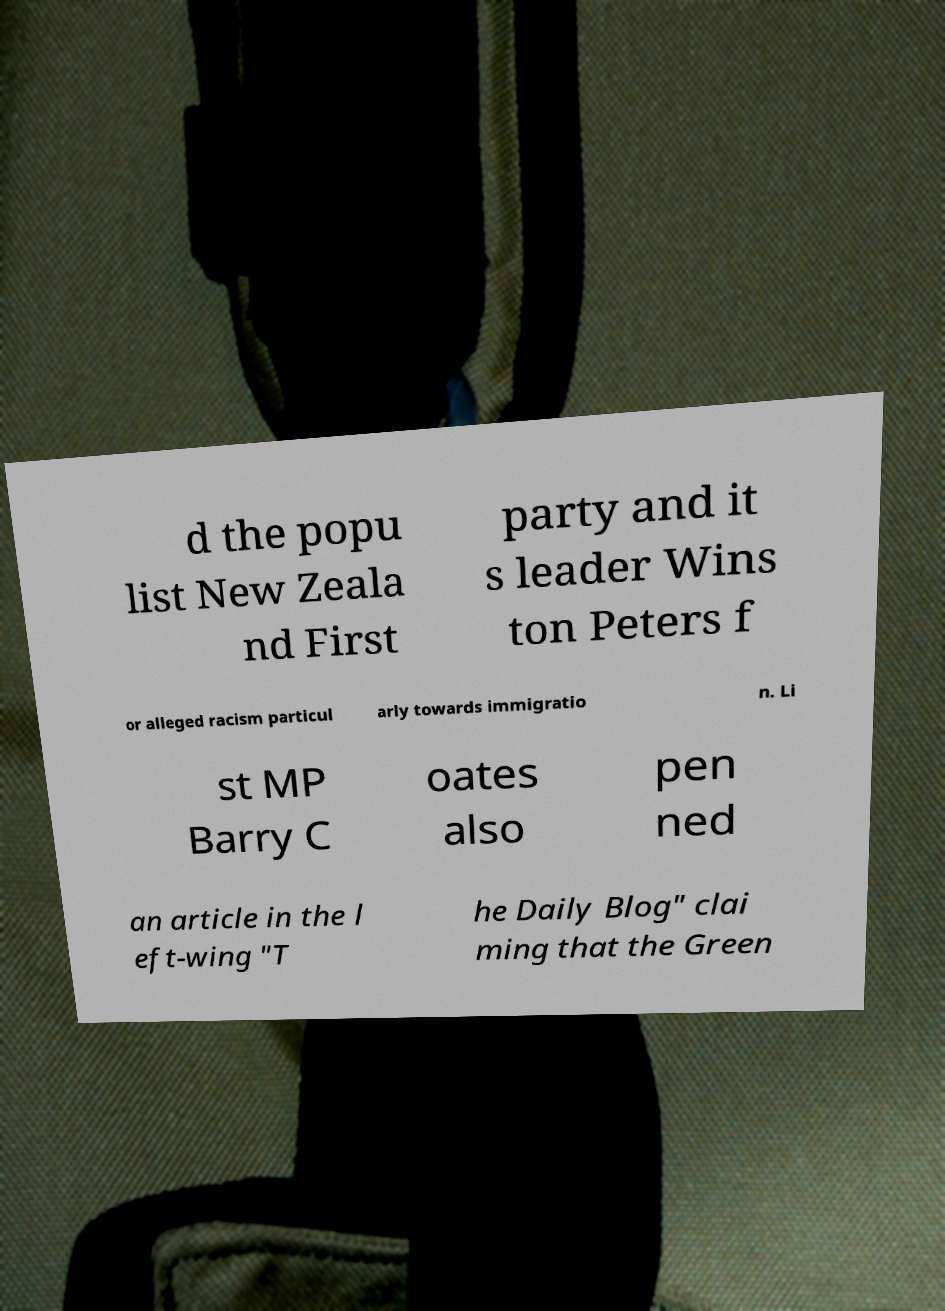What messages or text are displayed in this image? I need them in a readable, typed format. d the popu list New Zeala nd First party and it s leader Wins ton Peters f or alleged racism particul arly towards immigratio n. Li st MP Barry C oates also pen ned an article in the l eft-wing "T he Daily Blog" clai ming that the Green 